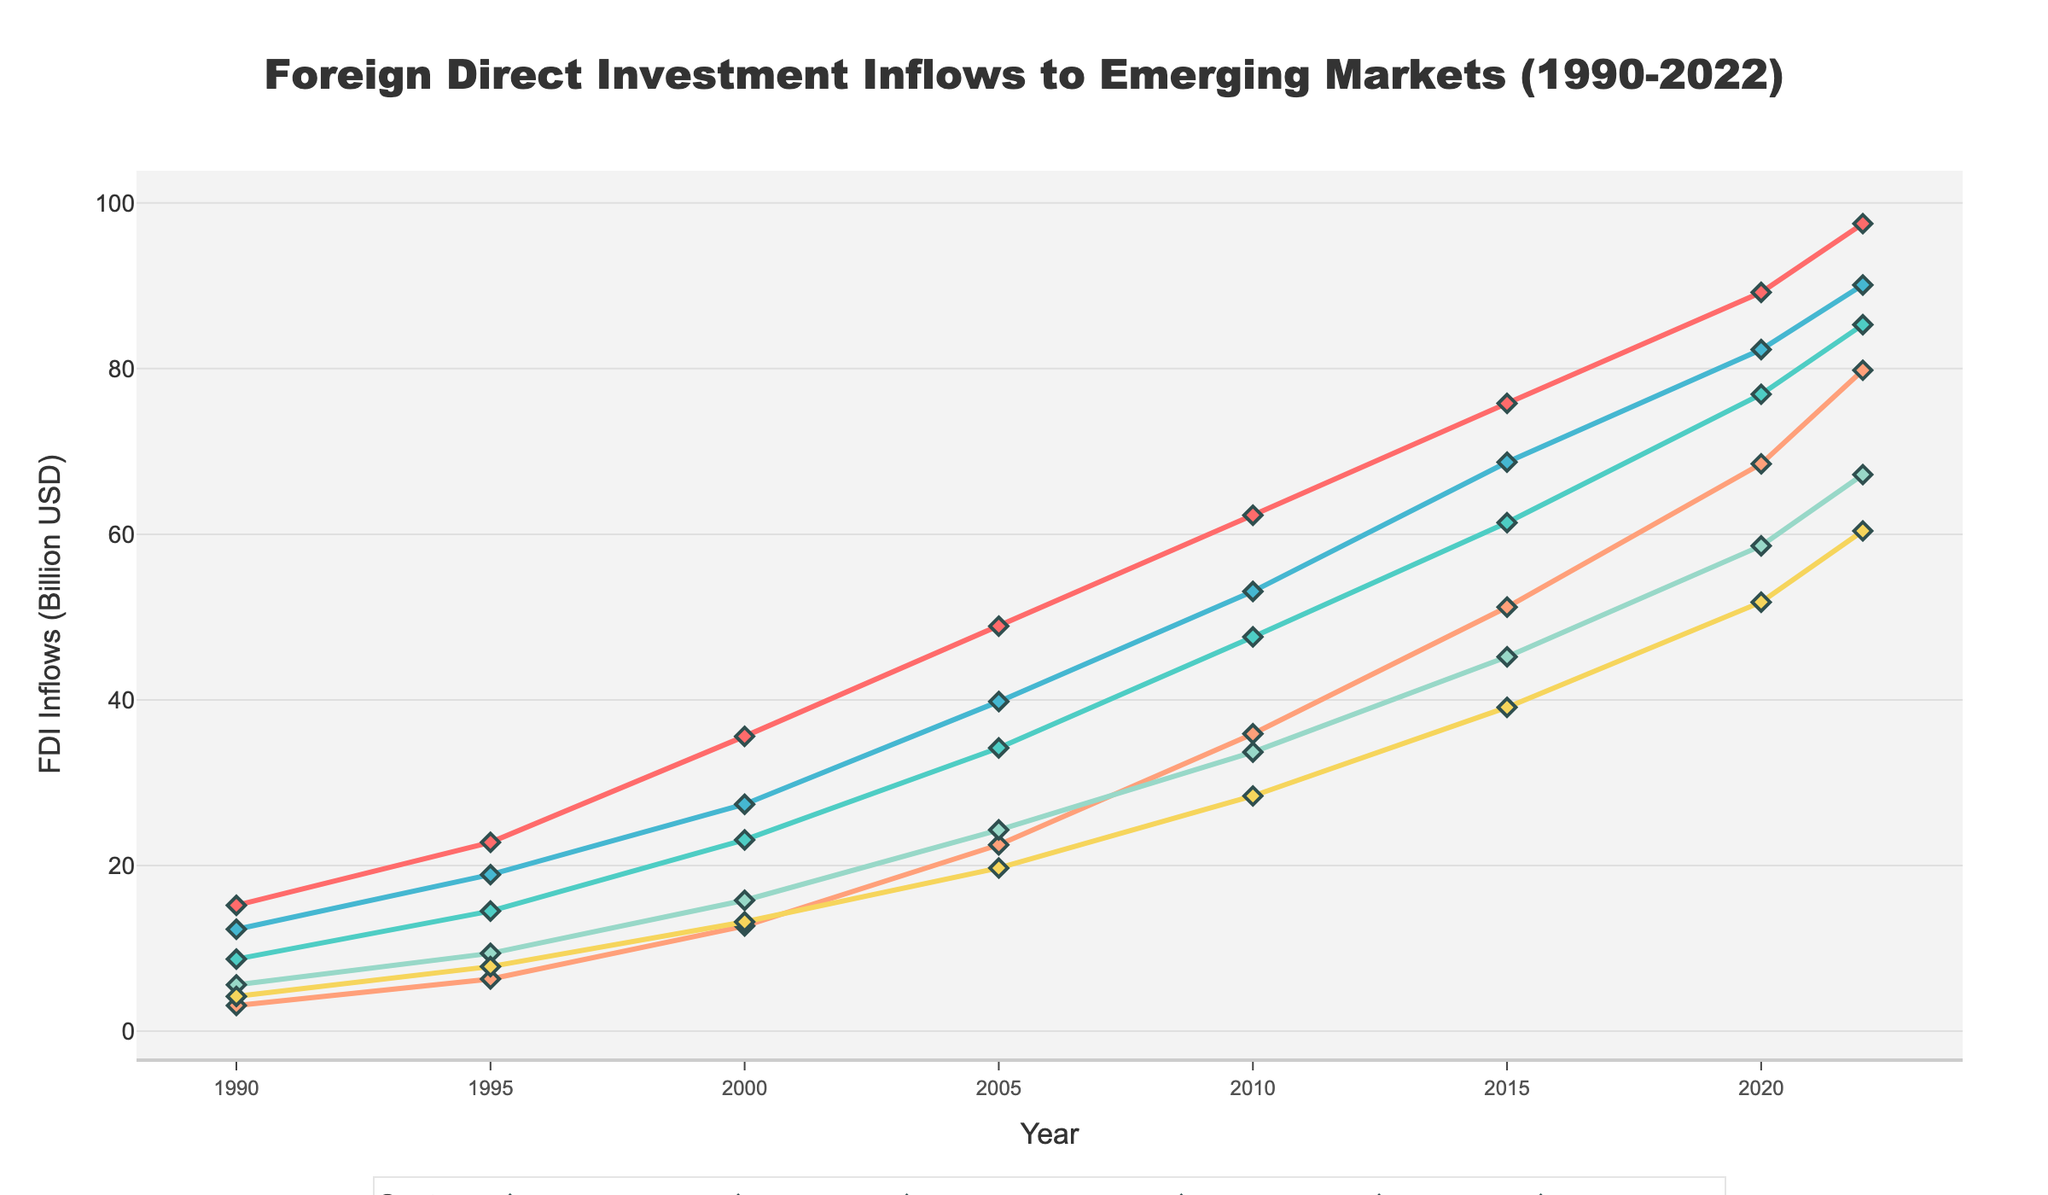What was the FDI inflow in the Manufacturing sector in 2005? Locate the Manufacturing line in the plot, then find the value corresponding to the year 2005.
Answer: 48.9 Which sector had the highest FDI inflow in 2022? Examine the endpoints of all the lines for the year 2022. The highest value corresponds to the Technology sector.
Answer: Technology Compare the FDI inflow between Natural Resources and Finance in 2010. Which one was higher? Look at the value of each sector for the year 2010. Natural Resources has an FDI of 53.1, while Finance has 33.7.
Answer: Natural Resources What is the overall trend for the Services sector from 1990 to 2022? Observe the trajectory of the Services line from 1990 to 2022. It shows a steady increase over the entire period.
Answer: Increasing Calculate the difference in FDI inflow between Infrastructure in 2020 and 2022. Locate the values for Infrastructure in 2020 (51.8) and 2022 (60.4). Subtract the 2020 value from the 2022 value: 60.4 - 51.8 = 8.6.
Answer: 8.6 What is the average FDI inflow in the Technology sector for the years 1990, 2000, and 2010? Sum the values for Technology in 1990 (3.1), 2000 (12.7), and 2010 (35.9), then divide by 3. Average = (3.1 + 12.7 + 35.9) / 3 = 17.23.
Answer: 17.23 How does the FDI inflow to Manufacturing compare between 1990 and 2022? Compare the values for Manufacturing in 1990 (15.2) and 2022 (97.5). 97.5 is significantly higher.
Answer: Higher in 2022 What is the percentage increase in FDI inflow for the Finance sector from 1990 to 2022? Calculate the difference between the values in 2022 (67.2) and 1990 (5.6), then divide by the 1990 value and multiply by 100: ((67.2 - 5.6) / 5.6) * 100 = 1100%.
Answer: 1100% Which sector experienced the most significant growth between 1995 and 2005? Calculate the difference between the 2005 and 1995 values for each sector. The largest difference is for Natural Resources: 39.8 - 18.9 = 20.9.
Answer: Natural Resources How did the FDI inflow in Infrastructure change from 2000 to 2010? Look at the values for Infrastructure in 2000 (13.2) and 2010 (28.4). The inflow increased.
Answer: Increased 